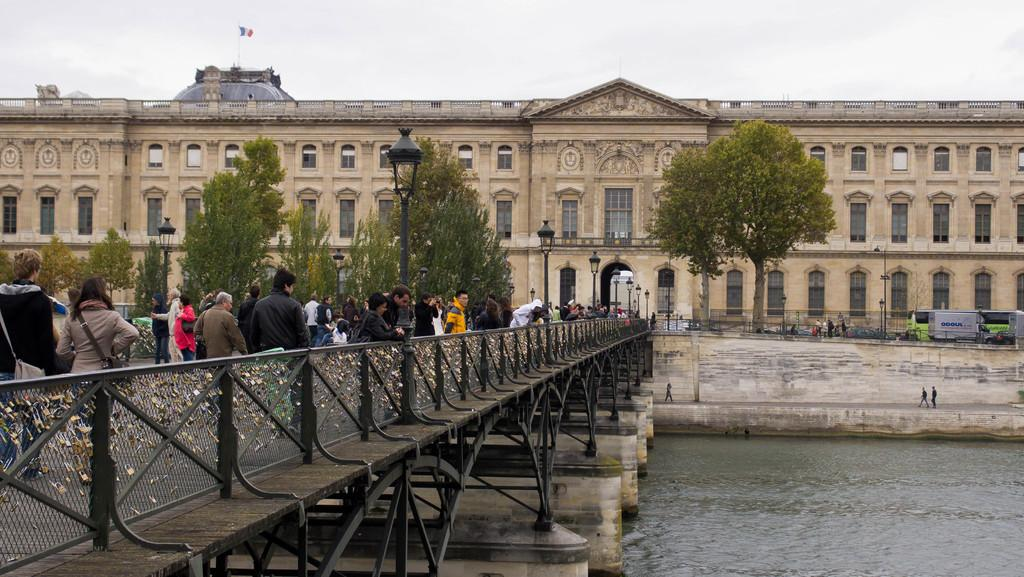How many people are in the image? There are people in the image, but the exact number is not specified. What structure can be seen in the image? There is a bridge in the image. What natural element is present in the image? There is water in the image. What architectural feature is visible in the image? There is a wall in the image. What type of lighting is present in the image? There are light poles in the image. What can be seen in the background of the image? There is a building, a vehicle, trees, and the sky visible in the background of the image. What type of table is being used for the activity in the image? There is no table or activity present in the image. How fast are the people running in the image? There are no people running in the image; they are likely walking or standing. 